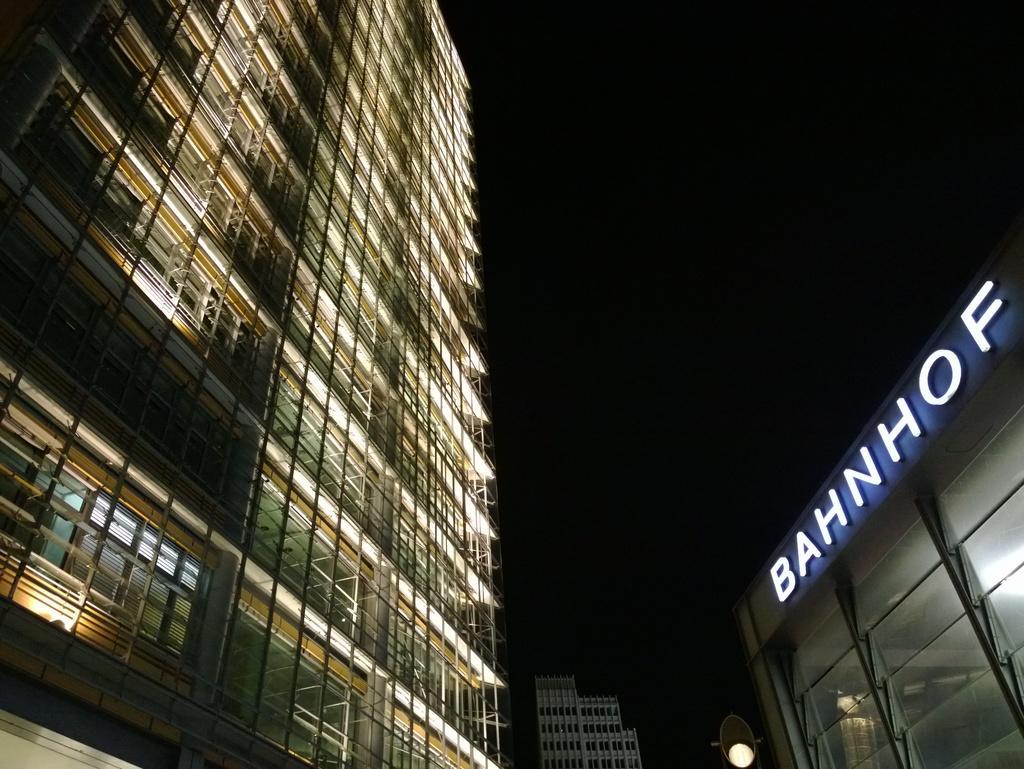How would you summarize this image in a sentence or two? In this picture I can see a buildings on the left and I see number of lights in it and on the right side of this picture I can see another building, on which there is something written. In the background I can see another building and I see that it is dark. 